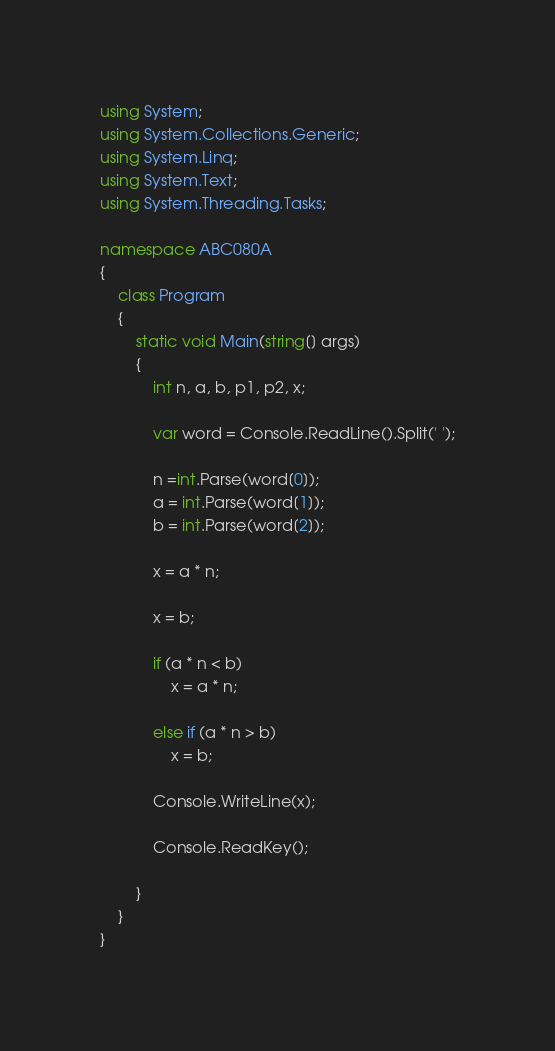Convert code to text. <code><loc_0><loc_0><loc_500><loc_500><_C#_>using System;
using System.Collections.Generic;
using System.Linq;
using System.Text;
using System.Threading.Tasks;

namespace ABC080A
{
    class Program
    {
        static void Main(string[] args)
        {
            int n, a, b, p1, p2, x;

            var word = Console.ReadLine().Split(' ');

            n =int.Parse(word[0]);
            a = int.Parse(word[1]);
            b = int.Parse(word[2]);

            x = a * n;

            x = b;

            if (a * n < b)
                x = a * n;

            else if (a * n > b) 
                x = b;

            Console.WriteLine(x);

            Console.ReadKey();

        }
    }
}
</code> 